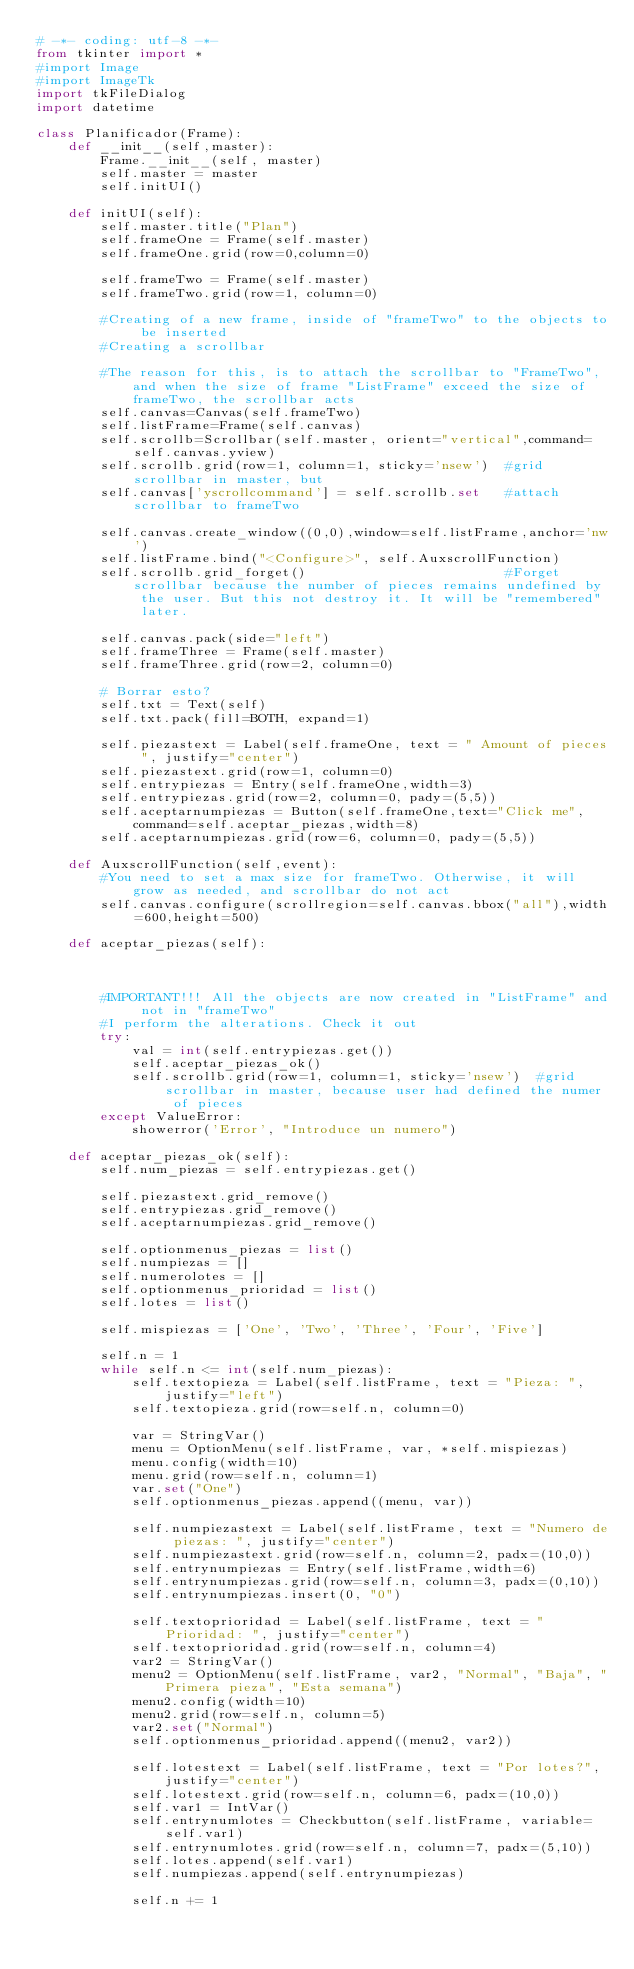Convert code to text. <code><loc_0><loc_0><loc_500><loc_500><_Python_># -*- coding: utf-8 -*-
from tkinter import *
#import Image
#import ImageTk
import tkFileDialog
import datetime

class Planificador(Frame):
    def __init__(self,master):
        Frame.__init__(self, master)
        self.master = master
        self.initUI()

    def initUI(self):
        self.master.title("Plan")
        self.frameOne = Frame(self.master)
        self.frameOne.grid(row=0,column=0)

        self.frameTwo = Frame(self.master)
        self.frameTwo.grid(row=1, column=0)

        #Creating of a new frame, inside of "frameTwo" to the objects to be inserted
        #Creating a scrollbar

        #The reason for this, is to attach the scrollbar to "FrameTwo", and when the size of frame "ListFrame" exceed the size of frameTwo, the scrollbar acts
        self.canvas=Canvas(self.frameTwo)
        self.listFrame=Frame(self.canvas)
        self.scrollb=Scrollbar(self.master, orient="vertical",command=self.canvas.yview)
        self.scrollb.grid(row=1, column=1, sticky='nsew')  #grid scrollbar in master, but
        self.canvas['yscrollcommand'] = self.scrollb.set   #attach scrollbar to frameTwo

        self.canvas.create_window((0,0),window=self.listFrame,anchor='nw')
        self.listFrame.bind("<Configure>", self.AuxscrollFunction)
        self.scrollb.grid_forget()                         #Forget scrollbar because the number of pieces remains undefined by the user. But this not destroy it. It will be "remembered" later.

        self.canvas.pack(side="left")
        self.frameThree = Frame(self.master)
        self.frameThree.grid(row=2, column=0)

        # Borrar esto?
        self.txt = Text(self)
        self.txt.pack(fill=BOTH, expand=1)

        self.piezastext = Label(self.frameOne, text = " Amount of pieces ", justify="center")
        self.piezastext.grid(row=1, column=0)
        self.entrypiezas = Entry(self.frameOne,width=3)
        self.entrypiezas.grid(row=2, column=0, pady=(5,5))
        self.aceptarnumpiezas = Button(self.frameOne,text="Click me", command=self.aceptar_piezas,width=8)
        self.aceptarnumpiezas.grid(row=6, column=0, pady=(5,5))

    def AuxscrollFunction(self,event):
        #You need to set a max size for frameTwo. Otherwise, it will grow as needed, and scrollbar do not act
        self.canvas.configure(scrollregion=self.canvas.bbox("all"),width=600,height=500)

    def aceptar_piezas(self):



        #IMPORTANT!!! All the objects are now created in "ListFrame" and not in "frameTwo"
        #I perform the alterations. Check it out
        try:
            val = int(self.entrypiezas.get())
            self.aceptar_piezas_ok()
            self.scrollb.grid(row=1, column=1, sticky='nsew')  #grid scrollbar in master, because user had defined the numer of pieces
        except ValueError:
            showerror('Error', "Introduce un numero")

    def aceptar_piezas_ok(self):
        self.num_piezas = self.entrypiezas.get()

        self.piezastext.grid_remove()
        self.entrypiezas.grid_remove()
        self.aceptarnumpiezas.grid_remove()

        self.optionmenus_piezas = list()
        self.numpiezas = []
        self.numerolotes = []
        self.optionmenus_prioridad = list()
        self.lotes = list()

        self.mispiezas = ['One', 'Two', 'Three', 'Four', 'Five']

        self.n = 1
        while self.n <= int(self.num_piezas):
            self.textopieza = Label(self.listFrame, text = "Pieza: ", justify="left")
            self.textopieza.grid(row=self.n, column=0)

            var = StringVar()
            menu = OptionMenu(self.listFrame, var, *self.mispiezas)
            menu.config(width=10)
            menu.grid(row=self.n, column=1)
            var.set("One")
            self.optionmenus_piezas.append((menu, var))

            self.numpiezastext = Label(self.listFrame, text = "Numero de piezas: ", justify="center")
            self.numpiezastext.grid(row=self.n, column=2, padx=(10,0))
            self.entrynumpiezas = Entry(self.listFrame,width=6)
            self.entrynumpiezas.grid(row=self.n, column=3, padx=(0,10))
            self.entrynumpiezas.insert(0, "0")

            self.textoprioridad = Label(self.listFrame, text = "Prioridad: ", justify="center")
            self.textoprioridad.grid(row=self.n, column=4)
            var2 = StringVar()
            menu2 = OptionMenu(self.listFrame, var2, "Normal", "Baja", "Primera pieza", "Esta semana")
            menu2.config(width=10)
            menu2.grid(row=self.n, column=5)
            var2.set("Normal")
            self.optionmenus_prioridad.append((menu2, var2))

            self.lotestext = Label(self.listFrame, text = "Por lotes?", justify="center")
            self.lotestext.grid(row=self.n, column=6, padx=(10,0))
            self.var1 = IntVar()
            self.entrynumlotes = Checkbutton(self.listFrame, variable=self.var1)
            self.entrynumlotes.grid(row=self.n, column=7, padx=(5,10))
            self.lotes.append(self.var1)
            self.numpiezas.append(self.entrynumpiezas)

            self.n += 1
</code> 